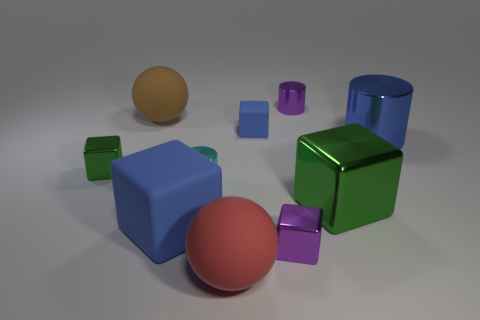Is there a block of the same color as the big metal cylinder?
Give a very brief answer. Yes. There is a large rubber object left of the big blue matte object; what shape is it?
Your answer should be very brief. Sphere. Does the cyan cylinder have the same material as the large green object?
Offer a terse response. Yes. What is the material of the other blue thing that is the same shape as the tiny blue object?
Offer a very short reply. Rubber. Is the number of big red matte objects that are in front of the tiny blue object less than the number of blue matte blocks?
Provide a succinct answer. Yes. There is a cyan object; what number of big green things are on the left side of it?
Give a very brief answer. 0. Is the shape of the metal object that is behind the brown rubber thing the same as the large blue thing to the right of the small matte thing?
Keep it short and to the point. Yes. The small metal object that is both in front of the purple metal cylinder and to the right of the cyan cylinder has what shape?
Your answer should be very brief. Cube. The cyan cylinder that is made of the same material as the big green cube is what size?
Offer a very short reply. Small. Are there fewer cyan cylinders than big objects?
Your answer should be compact. Yes. 